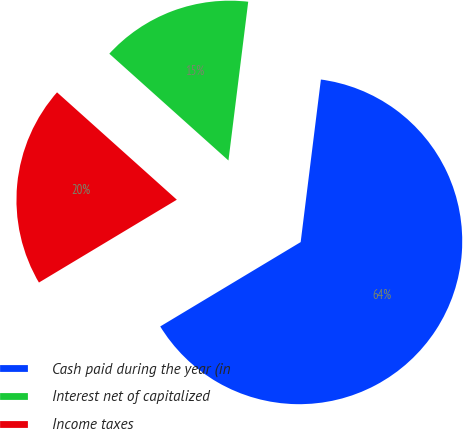Convert chart to OTSL. <chart><loc_0><loc_0><loc_500><loc_500><pie_chart><fcel>Cash paid during the year (in<fcel>Interest net of capitalized<fcel>Income taxes<nl><fcel>64.42%<fcel>15.34%<fcel>20.24%<nl></chart> 